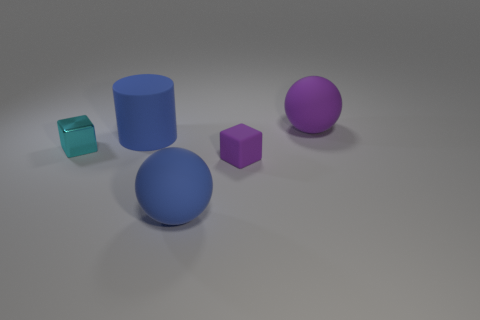Are there any other things that have the same material as the small cyan cube?
Your response must be concise. No. Are there fewer small cyan cubes behind the large purple ball than metallic things on the left side of the tiny cyan metallic object?
Make the answer very short. No. Is there anything else that has the same size as the purple cube?
Provide a succinct answer. Yes. There is a cyan thing; what shape is it?
Give a very brief answer. Cube. What material is the tiny thing that is on the right side of the blue rubber cylinder?
Offer a terse response. Rubber. There is a rubber ball in front of the matte ball that is behind the big sphere in front of the cyan cube; how big is it?
Give a very brief answer. Large. Does the blue cylinder behind the tiny matte object have the same material as the blue thing that is in front of the small metal cube?
Make the answer very short. Yes. How many other things are the same color as the rubber cylinder?
Provide a succinct answer. 1. What number of objects are big matte objects that are in front of the cyan metal cube or matte objects left of the large purple rubber ball?
Provide a succinct answer. 3. There is a object left of the large blue matte thing behind the tiny cyan shiny thing; what size is it?
Give a very brief answer. Small. 